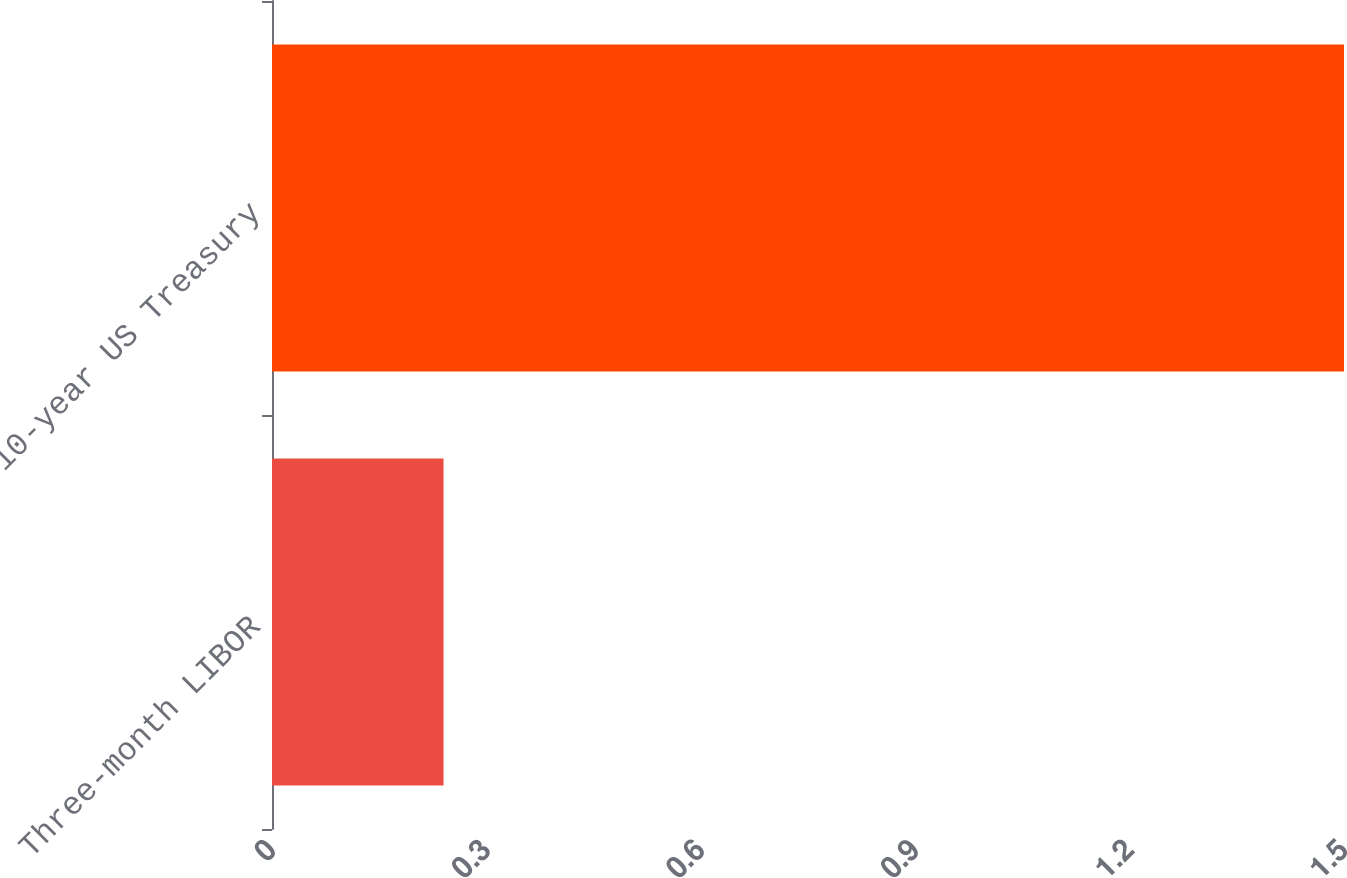Convert chart to OTSL. <chart><loc_0><loc_0><loc_500><loc_500><bar_chart><fcel>Three-month LIBOR<fcel>10-year US Treasury<nl><fcel>0.24<fcel>1.5<nl></chart> 